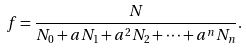<formula> <loc_0><loc_0><loc_500><loc_500>f = \frac { N } { N _ { 0 } + a N _ { 1 } + a ^ { 2 } N _ { 2 } + \dots + a ^ { n } N _ { n } } .</formula> 